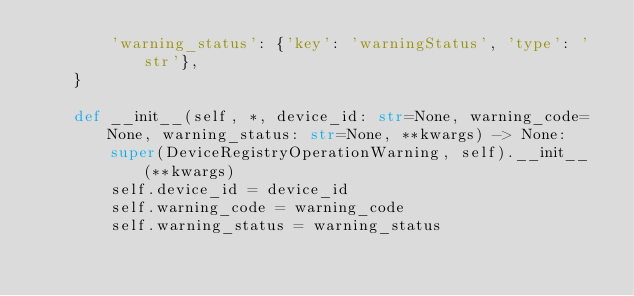<code> <loc_0><loc_0><loc_500><loc_500><_Python_>        'warning_status': {'key': 'warningStatus', 'type': 'str'},
    }

    def __init__(self, *, device_id: str=None, warning_code=None, warning_status: str=None, **kwargs) -> None:
        super(DeviceRegistryOperationWarning, self).__init__(**kwargs)
        self.device_id = device_id
        self.warning_code = warning_code
        self.warning_status = warning_status
</code> 